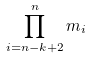<formula> <loc_0><loc_0><loc_500><loc_500>\prod _ { i = n - k + 2 } ^ { n } m _ { i }</formula> 